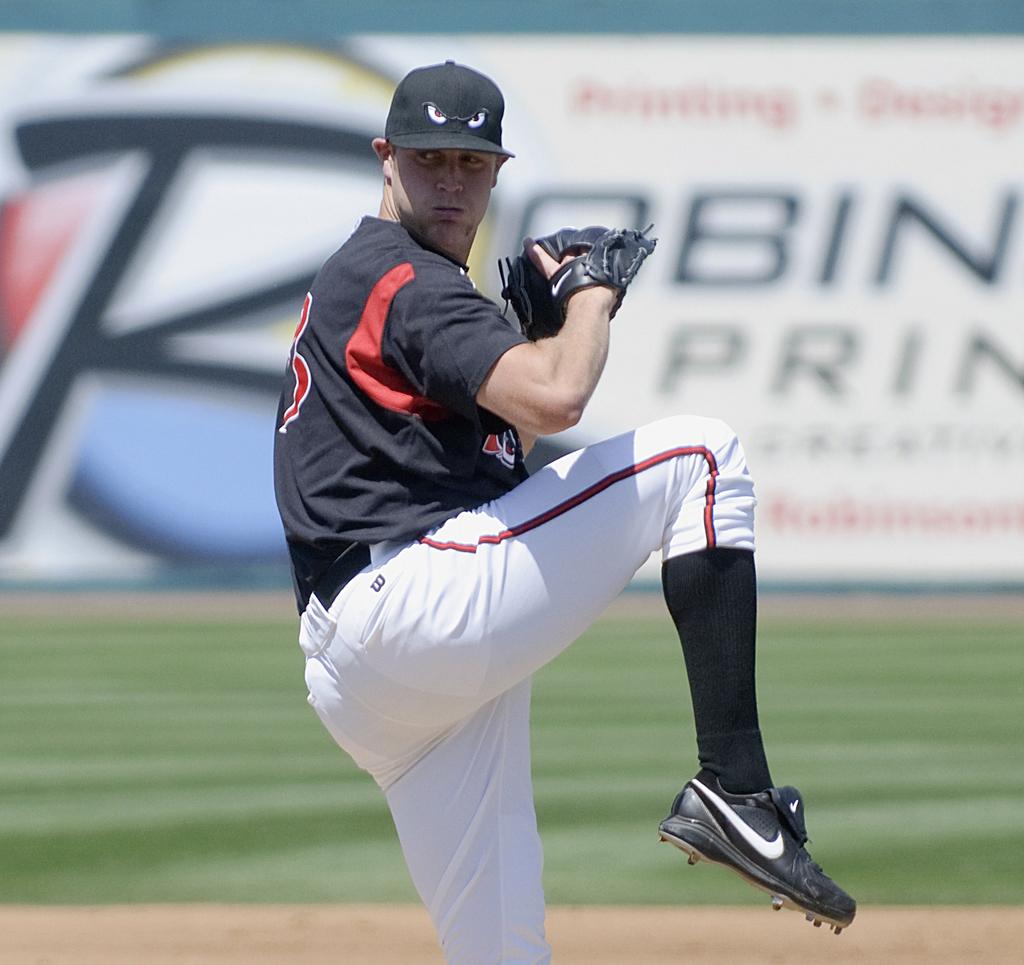What kind of shoes is he wearing?
Provide a short and direct response. Nike. 